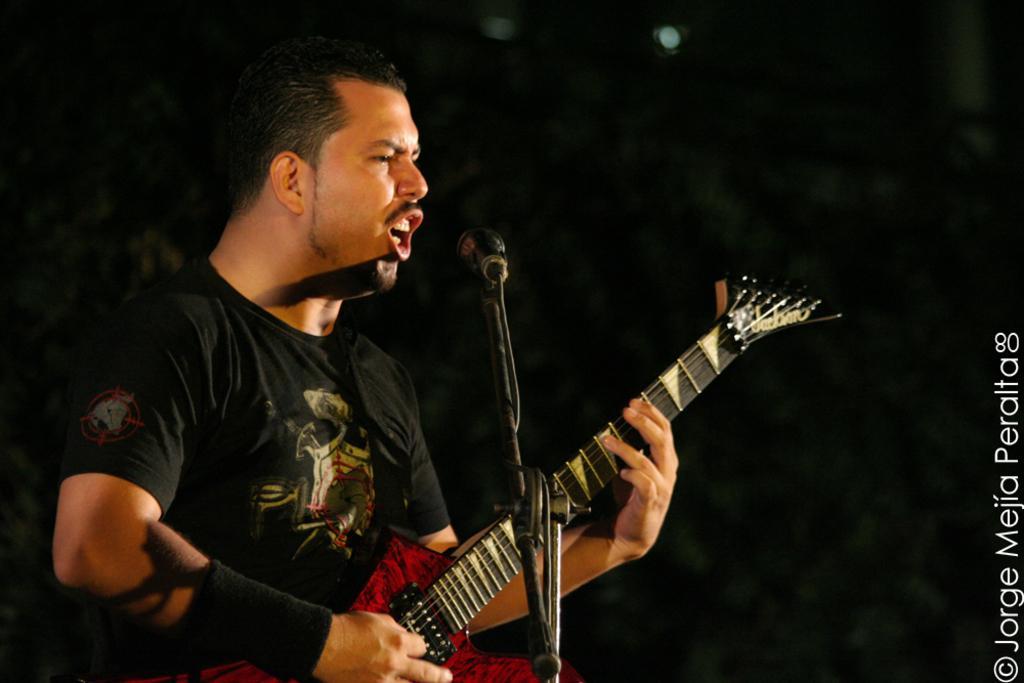Can you describe this image briefly? In this picture we can see man holding guitar in his hand and singing on mic and in background we can see light and it is so dark. 